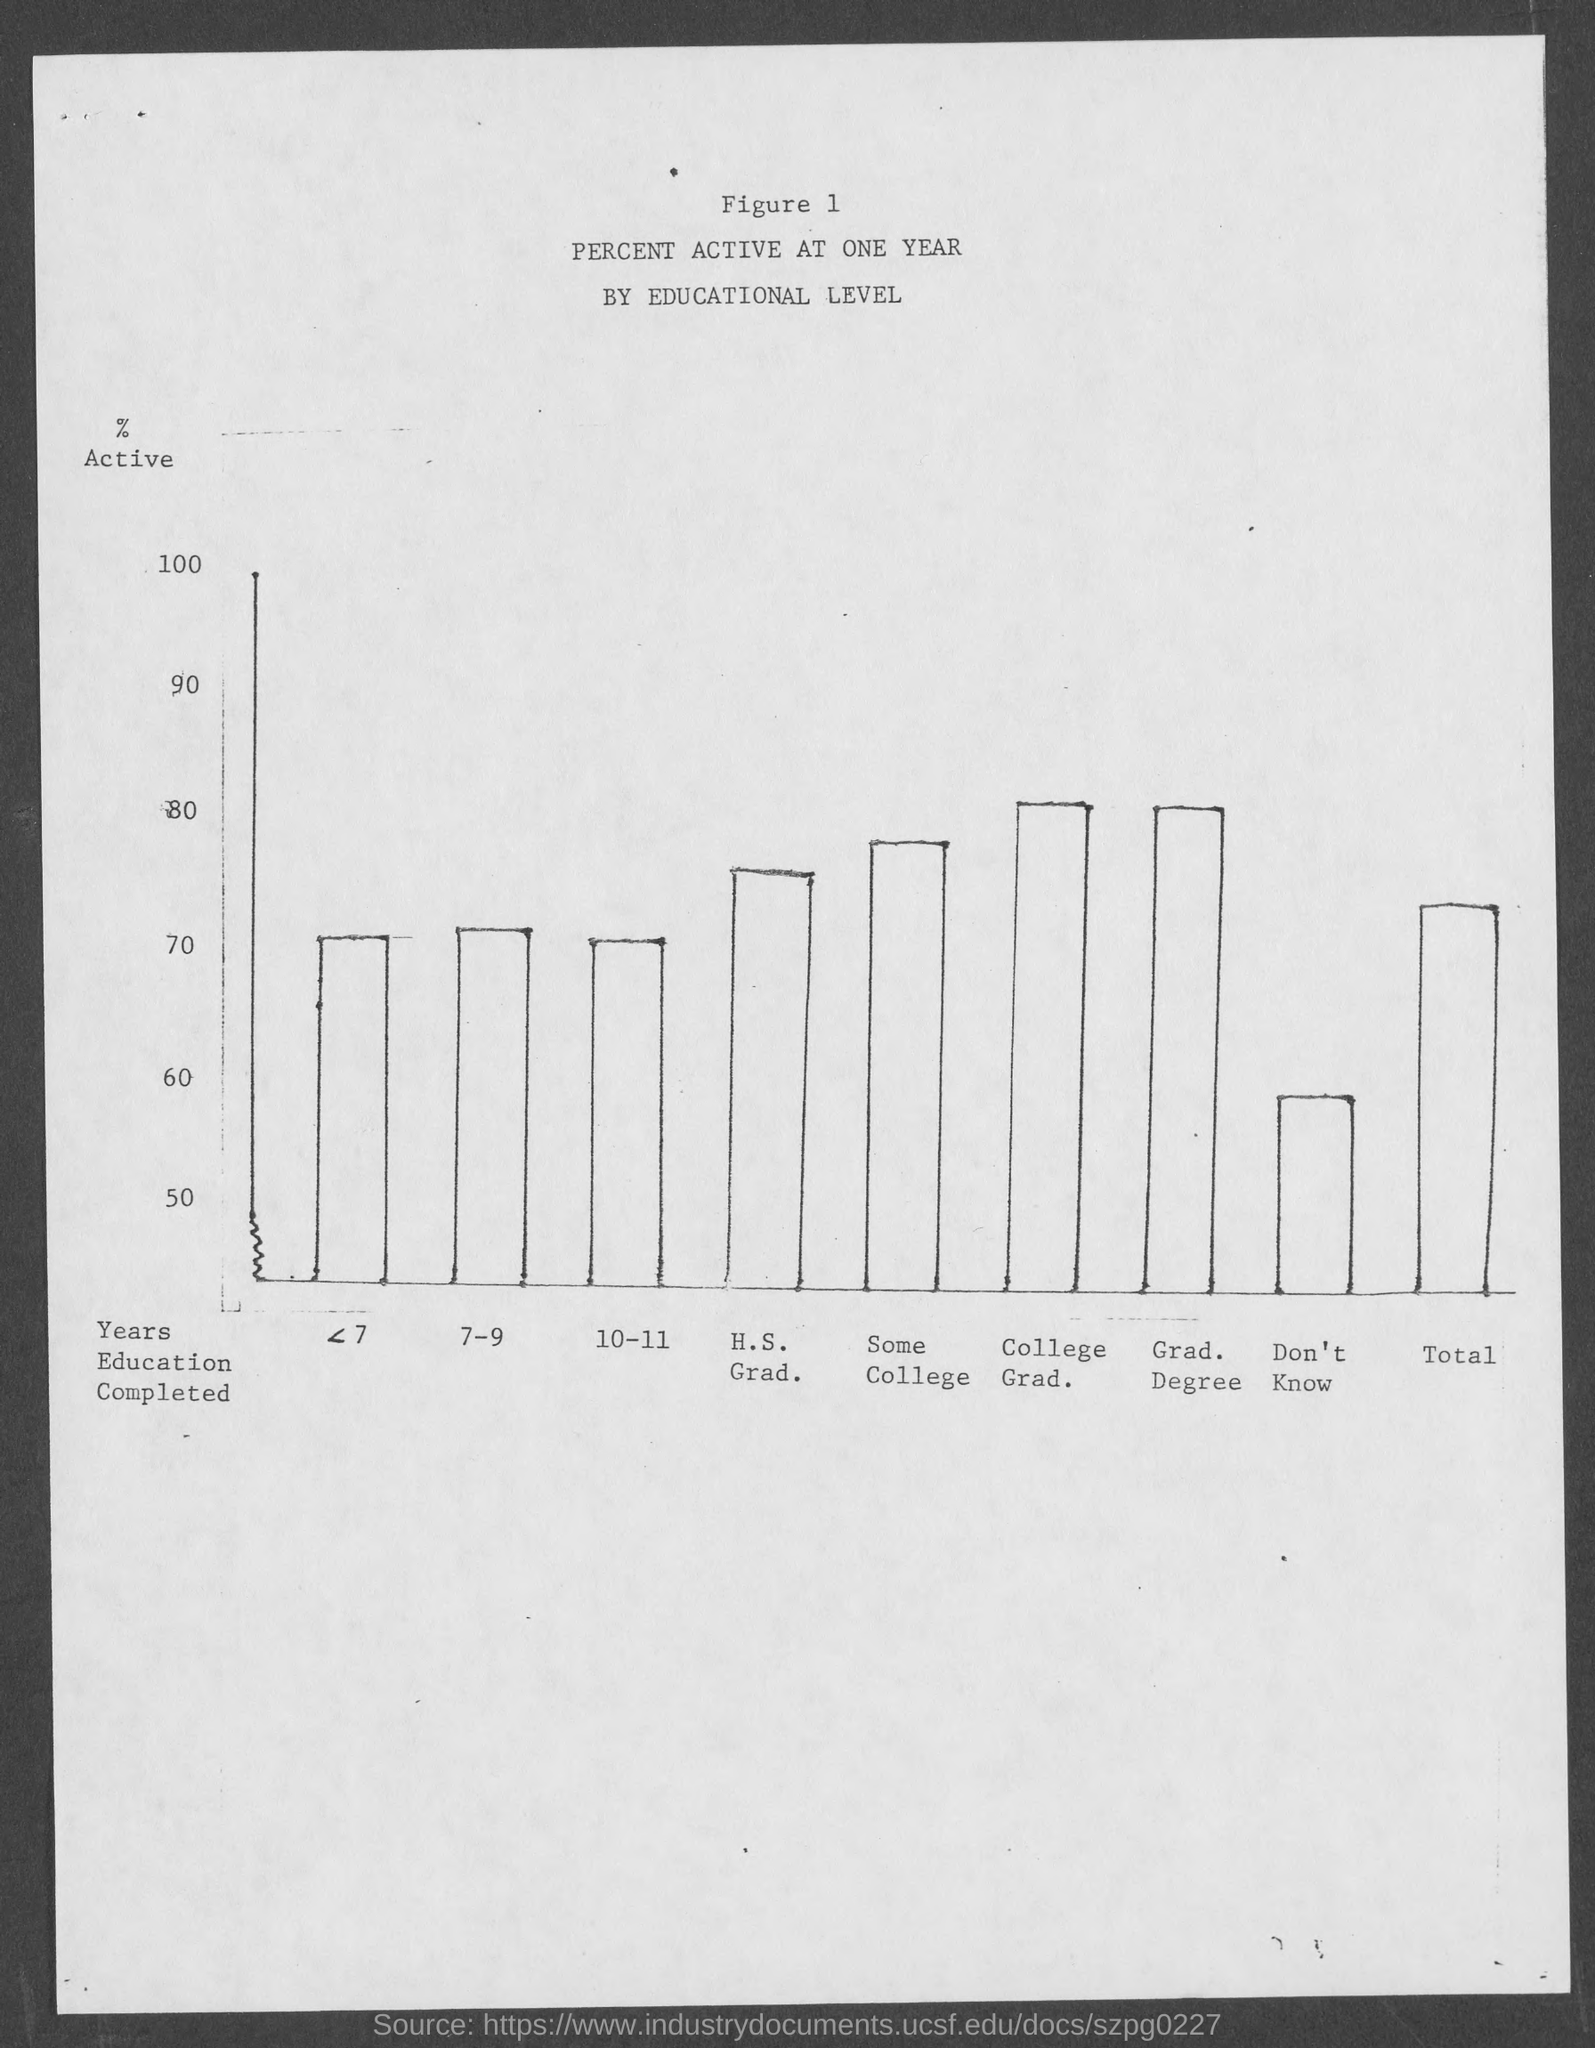What is the figure number?
Provide a short and direct response. 1. What is the title?
Your answer should be compact. Percent active at one year by educational level. 